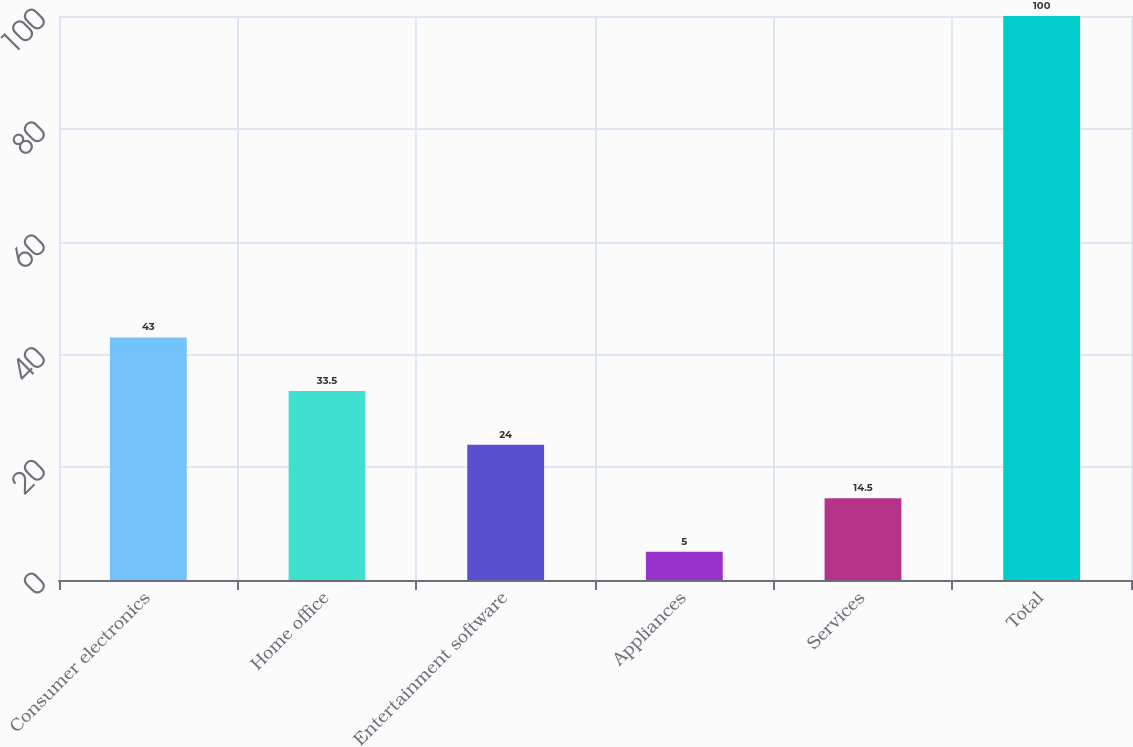Convert chart to OTSL. <chart><loc_0><loc_0><loc_500><loc_500><bar_chart><fcel>Consumer electronics<fcel>Home office<fcel>Entertainment software<fcel>Appliances<fcel>Services<fcel>Total<nl><fcel>43<fcel>33.5<fcel>24<fcel>5<fcel>14.5<fcel>100<nl></chart> 